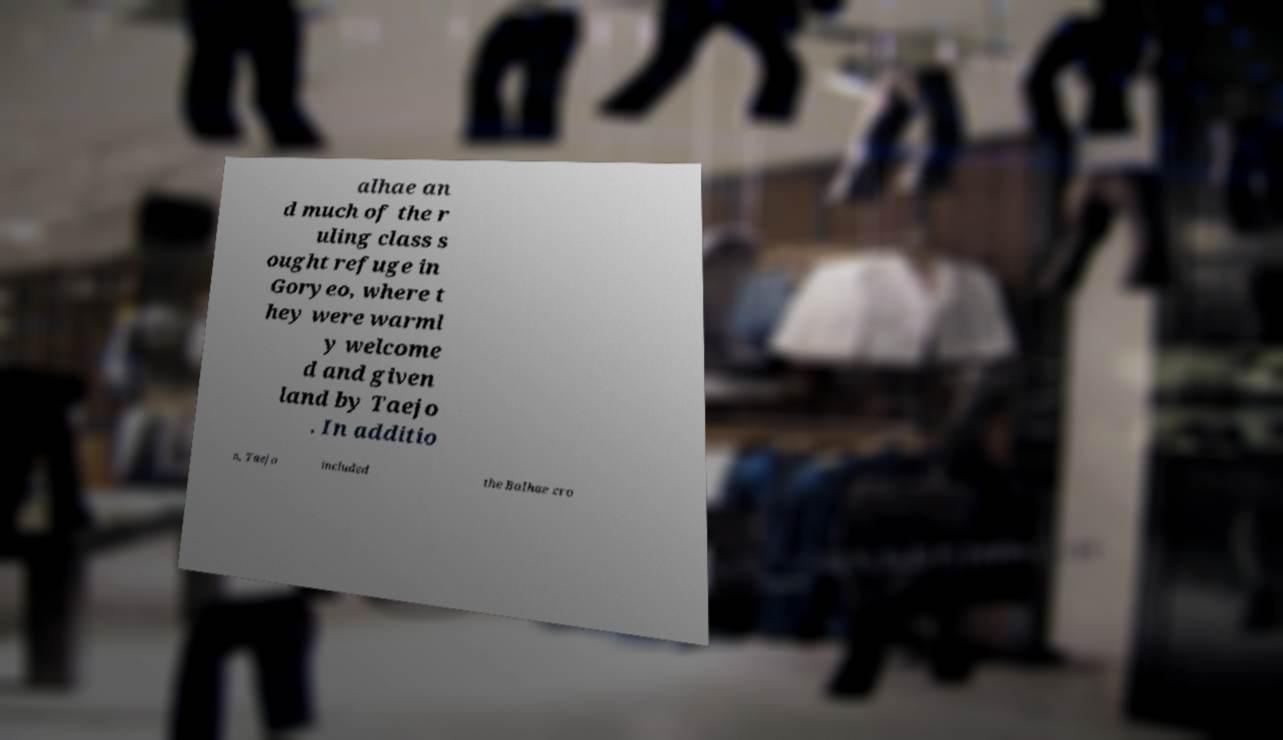What messages or text are displayed in this image? I need them in a readable, typed format. alhae an d much of the r uling class s ought refuge in Goryeo, where t hey were warml y welcome d and given land by Taejo . In additio n, Taejo included the Balhae cro 